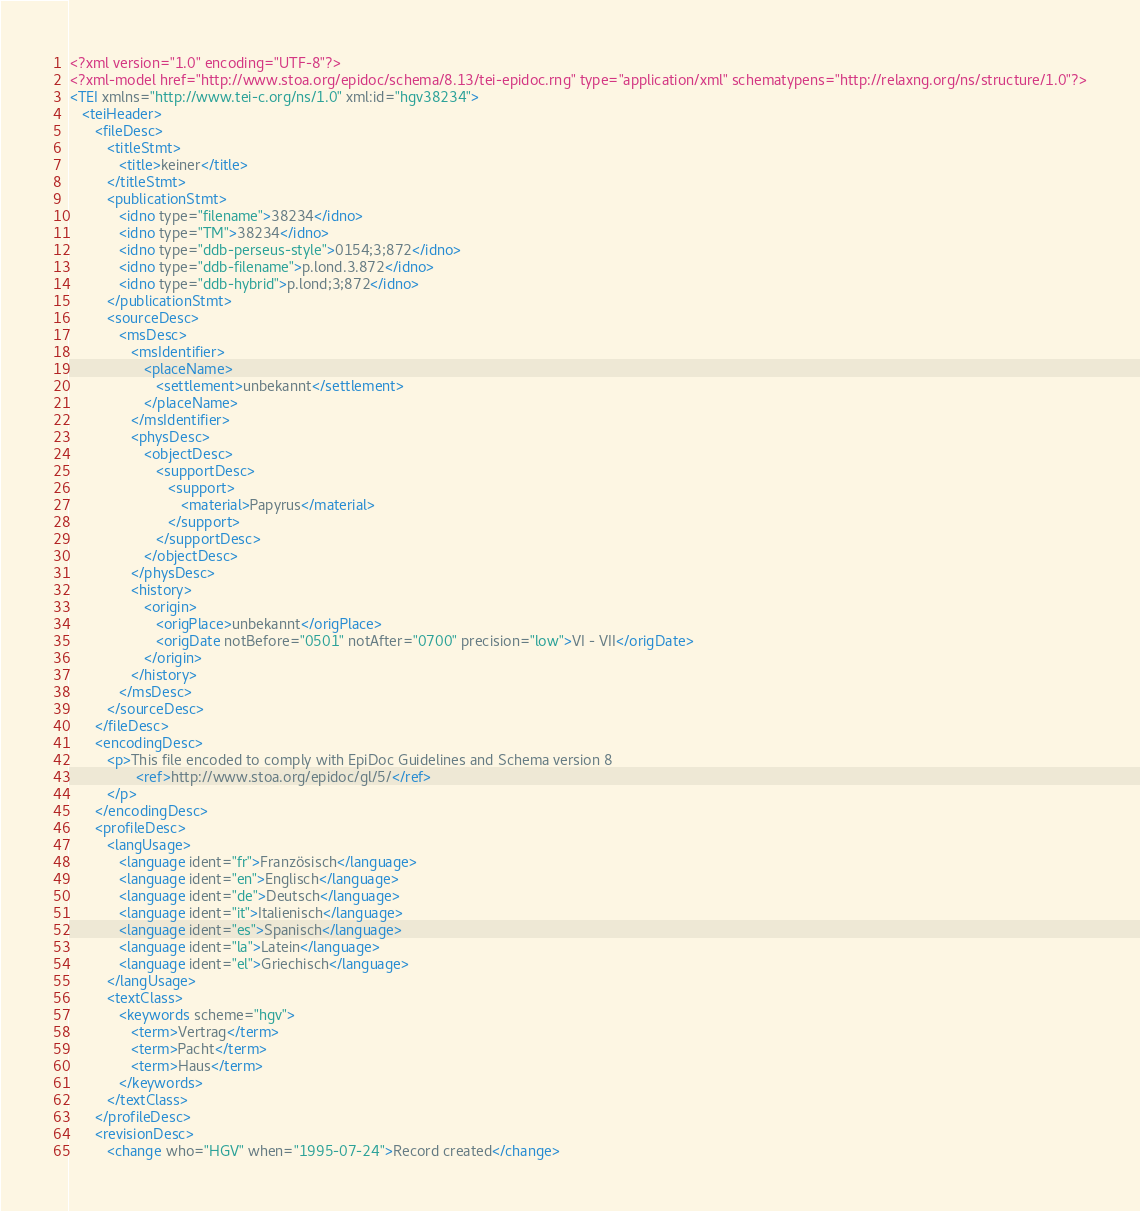<code> <loc_0><loc_0><loc_500><loc_500><_XML_><?xml version="1.0" encoding="UTF-8"?>
<?xml-model href="http://www.stoa.org/epidoc/schema/8.13/tei-epidoc.rng" type="application/xml" schematypens="http://relaxng.org/ns/structure/1.0"?>
<TEI xmlns="http://www.tei-c.org/ns/1.0" xml:id="hgv38234">
   <teiHeader>
      <fileDesc>
         <titleStmt>
            <title>keiner</title>
         </titleStmt>
         <publicationStmt>
            <idno type="filename">38234</idno>
            <idno type="TM">38234</idno>
            <idno type="ddb-perseus-style">0154;3;872</idno>
            <idno type="ddb-filename">p.lond.3.872</idno>
            <idno type="ddb-hybrid">p.lond;3;872</idno>
         </publicationStmt>
         <sourceDesc>
            <msDesc>
               <msIdentifier>
                  <placeName>
                     <settlement>unbekannt</settlement>
                  </placeName>
               </msIdentifier>
               <physDesc>
                  <objectDesc>
                     <supportDesc>
                        <support>
                           <material>Papyrus</material>
                        </support>
                     </supportDesc>
                  </objectDesc>
               </physDesc>
               <history>
                  <origin>
                     <origPlace>unbekannt</origPlace>
                     <origDate notBefore="0501" notAfter="0700" precision="low">VI - VII</origDate>
                  </origin>
               </history>
            </msDesc>
         </sourceDesc>
      </fileDesc>
      <encodingDesc>
         <p>This file encoded to comply with EpiDoc Guidelines and Schema version 8
                <ref>http://www.stoa.org/epidoc/gl/5/</ref>
         </p>
      </encodingDesc>
      <profileDesc>
         <langUsage>
            <language ident="fr">Französisch</language>
            <language ident="en">Englisch</language>
            <language ident="de">Deutsch</language>
            <language ident="it">Italienisch</language>
            <language ident="es">Spanisch</language>
            <language ident="la">Latein</language>
            <language ident="el">Griechisch</language>
         </langUsage>
         <textClass>
            <keywords scheme="hgv">
               <term>Vertrag</term>
               <term>Pacht</term>
               <term>Haus</term>
            </keywords>
         </textClass>
      </profileDesc>
      <revisionDesc>
         <change who="HGV" when="1995-07-24">Record created</change></code> 